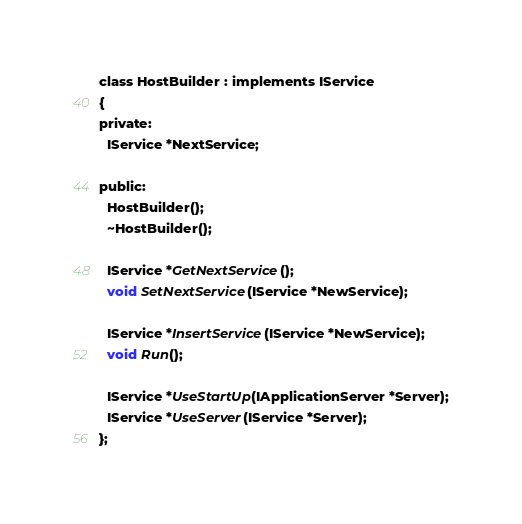<code> <loc_0><loc_0><loc_500><loc_500><_C_>class HostBuilder : implements IService
{
private:
  IService *NextService;

public:
  HostBuilder();
  ~HostBuilder();

  IService *GetNextService();
  void SetNextService(IService *NewService);

  IService *InsertService(IService *NewService);
  void Run();

  IService *UseStartUp(IApplicationServer *Server);
  IService *UseServer(IService *Server);
};</code> 